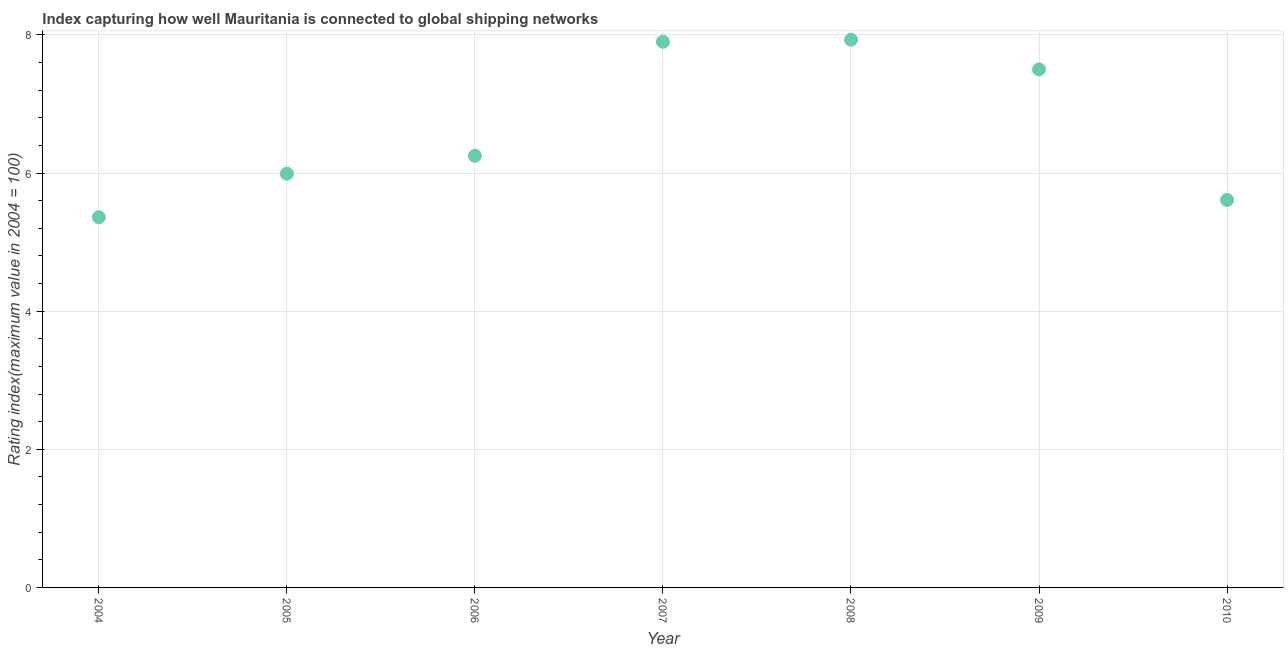What is the liner shipping connectivity index in 2006?
Offer a terse response. 6.25. Across all years, what is the maximum liner shipping connectivity index?
Your answer should be very brief. 7.93. Across all years, what is the minimum liner shipping connectivity index?
Provide a succinct answer. 5.36. In which year was the liner shipping connectivity index minimum?
Give a very brief answer. 2004. What is the sum of the liner shipping connectivity index?
Offer a terse response. 46.54. What is the difference between the liner shipping connectivity index in 2008 and 2010?
Make the answer very short. 2.32. What is the average liner shipping connectivity index per year?
Give a very brief answer. 6.65. What is the median liner shipping connectivity index?
Provide a short and direct response. 6.25. What is the ratio of the liner shipping connectivity index in 2006 to that in 2009?
Provide a short and direct response. 0.83. Is the liner shipping connectivity index in 2008 less than that in 2009?
Your response must be concise. No. Is the difference between the liner shipping connectivity index in 2006 and 2008 greater than the difference between any two years?
Your answer should be compact. No. What is the difference between the highest and the second highest liner shipping connectivity index?
Keep it short and to the point. 0.03. What is the difference between the highest and the lowest liner shipping connectivity index?
Offer a very short reply. 2.57. In how many years, is the liner shipping connectivity index greater than the average liner shipping connectivity index taken over all years?
Offer a terse response. 3. Does the liner shipping connectivity index monotonically increase over the years?
Give a very brief answer. No. How many dotlines are there?
Provide a short and direct response. 1. How many years are there in the graph?
Keep it short and to the point. 7. Does the graph contain any zero values?
Make the answer very short. No. Does the graph contain grids?
Offer a terse response. Yes. What is the title of the graph?
Keep it short and to the point. Index capturing how well Mauritania is connected to global shipping networks. What is the label or title of the X-axis?
Ensure brevity in your answer.  Year. What is the label or title of the Y-axis?
Make the answer very short. Rating index(maximum value in 2004 = 100). What is the Rating index(maximum value in 2004 = 100) in 2004?
Your answer should be compact. 5.36. What is the Rating index(maximum value in 2004 = 100) in 2005?
Keep it short and to the point. 5.99. What is the Rating index(maximum value in 2004 = 100) in 2006?
Ensure brevity in your answer.  6.25. What is the Rating index(maximum value in 2004 = 100) in 2007?
Make the answer very short. 7.9. What is the Rating index(maximum value in 2004 = 100) in 2008?
Give a very brief answer. 7.93. What is the Rating index(maximum value in 2004 = 100) in 2010?
Provide a succinct answer. 5.61. What is the difference between the Rating index(maximum value in 2004 = 100) in 2004 and 2005?
Offer a terse response. -0.63. What is the difference between the Rating index(maximum value in 2004 = 100) in 2004 and 2006?
Keep it short and to the point. -0.89. What is the difference between the Rating index(maximum value in 2004 = 100) in 2004 and 2007?
Your answer should be very brief. -2.54. What is the difference between the Rating index(maximum value in 2004 = 100) in 2004 and 2008?
Provide a short and direct response. -2.57. What is the difference between the Rating index(maximum value in 2004 = 100) in 2004 and 2009?
Make the answer very short. -2.14. What is the difference between the Rating index(maximum value in 2004 = 100) in 2004 and 2010?
Your answer should be very brief. -0.25. What is the difference between the Rating index(maximum value in 2004 = 100) in 2005 and 2006?
Offer a very short reply. -0.26. What is the difference between the Rating index(maximum value in 2004 = 100) in 2005 and 2007?
Your answer should be compact. -1.91. What is the difference between the Rating index(maximum value in 2004 = 100) in 2005 and 2008?
Ensure brevity in your answer.  -1.94. What is the difference between the Rating index(maximum value in 2004 = 100) in 2005 and 2009?
Your response must be concise. -1.51. What is the difference between the Rating index(maximum value in 2004 = 100) in 2005 and 2010?
Ensure brevity in your answer.  0.38. What is the difference between the Rating index(maximum value in 2004 = 100) in 2006 and 2007?
Give a very brief answer. -1.65. What is the difference between the Rating index(maximum value in 2004 = 100) in 2006 and 2008?
Offer a terse response. -1.68. What is the difference between the Rating index(maximum value in 2004 = 100) in 2006 and 2009?
Give a very brief answer. -1.25. What is the difference between the Rating index(maximum value in 2004 = 100) in 2006 and 2010?
Keep it short and to the point. 0.64. What is the difference between the Rating index(maximum value in 2004 = 100) in 2007 and 2008?
Give a very brief answer. -0.03. What is the difference between the Rating index(maximum value in 2004 = 100) in 2007 and 2010?
Give a very brief answer. 2.29. What is the difference between the Rating index(maximum value in 2004 = 100) in 2008 and 2009?
Ensure brevity in your answer.  0.43. What is the difference between the Rating index(maximum value in 2004 = 100) in 2008 and 2010?
Your response must be concise. 2.32. What is the difference between the Rating index(maximum value in 2004 = 100) in 2009 and 2010?
Offer a terse response. 1.89. What is the ratio of the Rating index(maximum value in 2004 = 100) in 2004 to that in 2005?
Offer a terse response. 0.9. What is the ratio of the Rating index(maximum value in 2004 = 100) in 2004 to that in 2006?
Offer a terse response. 0.86. What is the ratio of the Rating index(maximum value in 2004 = 100) in 2004 to that in 2007?
Your answer should be compact. 0.68. What is the ratio of the Rating index(maximum value in 2004 = 100) in 2004 to that in 2008?
Make the answer very short. 0.68. What is the ratio of the Rating index(maximum value in 2004 = 100) in 2004 to that in 2009?
Give a very brief answer. 0.71. What is the ratio of the Rating index(maximum value in 2004 = 100) in 2004 to that in 2010?
Provide a succinct answer. 0.95. What is the ratio of the Rating index(maximum value in 2004 = 100) in 2005 to that in 2006?
Give a very brief answer. 0.96. What is the ratio of the Rating index(maximum value in 2004 = 100) in 2005 to that in 2007?
Your response must be concise. 0.76. What is the ratio of the Rating index(maximum value in 2004 = 100) in 2005 to that in 2008?
Give a very brief answer. 0.76. What is the ratio of the Rating index(maximum value in 2004 = 100) in 2005 to that in 2009?
Provide a short and direct response. 0.8. What is the ratio of the Rating index(maximum value in 2004 = 100) in 2005 to that in 2010?
Your answer should be very brief. 1.07. What is the ratio of the Rating index(maximum value in 2004 = 100) in 2006 to that in 2007?
Make the answer very short. 0.79. What is the ratio of the Rating index(maximum value in 2004 = 100) in 2006 to that in 2008?
Give a very brief answer. 0.79. What is the ratio of the Rating index(maximum value in 2004 = 100) in 2006 to that in 2009?
Provide a succinct answer. 0.83. What is the ratio of the Rating index(maximum value in 2004 = 100) in 2006 to that in 2010?
Your answer should be very brief. 1.11. What is the ratio of the Rating index(maximum value in 2004 = 100) in 2007 to that in 2009?
Keep it short and to the point. 1.05. What is the ratio of the Rating index(maximum value in 2004 = 100) in 2007 to that in 2010?
Your response must be concise. 1.41. What is the ratio of the Rating index(maximum value in 2004 = 100) in 2008 to that in 2009?
Provide a succinct answer. 1.06. What is the ratio of the Rating index(maximum value in 2004 = 100) in 2008 to that in 2010?
Provide a short and direct response. 1.41. What is the ratio of the Rating index(maximum value in 2004 = 100) in 2009 to that in 2010?
Your response must be concise. 1.34. 